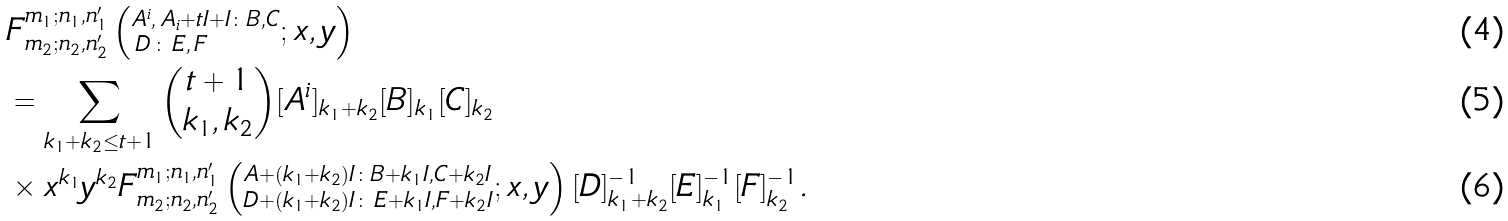Convert formula to latex. <formula><loc_0><loc_0><loc_500><loc_500>& F ^ { m _ { 1 } ; n _ { 1 } , n ^ { \prime } _ { 1 } } _ { m _ { 2 } ; n _ { 2 } , n ^ { \prime } _ { 2 } } \left ( ^ { A ^ { i } , \, A _ { i } + t I + I \colon B , C } _ { \, D \, \colon \, E , \, F } ; x , y \right ) \\ & = \sum _ { k _ { 1 } + k _ { 2 } \leq t + 1 } { t + 1 \choose k _ { 1 } , k _ { 2 } } { [ A ^ { i } ] _ { k _ { 1 } + k _ { 2 } } [ B ] _ { k _ { 1 } } } [ C ] _ { k _ { 2 } } \, \\ & \times x ^ { k _ { 1 } } y ^ { k _ { 2 } } F ^ { m _ { 1 } ; n _ { 1 } , n ^ { \prime } _ { 1 } } _ { m _ { 2 } ; n _ { 2 } , n ^ { \prime } _ { 2 } } \left ( ^ { A + ( k _ { 1 } + k _ { 2 } ) I \colon B + k _ { 1 } I , C + k _ { 2 } I } _ { D + ( k _ { 1 } + k _ { 2 } ) I \colon \, E + k _ { 1 } I , F + k _ { 2 } I } ; x , y \right ) { [ D ] ^ { - 1 } _ { k _ { 1 } + k _ { 2 } } [ E ] ^ { - 1 } _ { k _ { 1 } } [ F ] ^ { - 1 } _ { k _ { 2 } } } .</formula> 